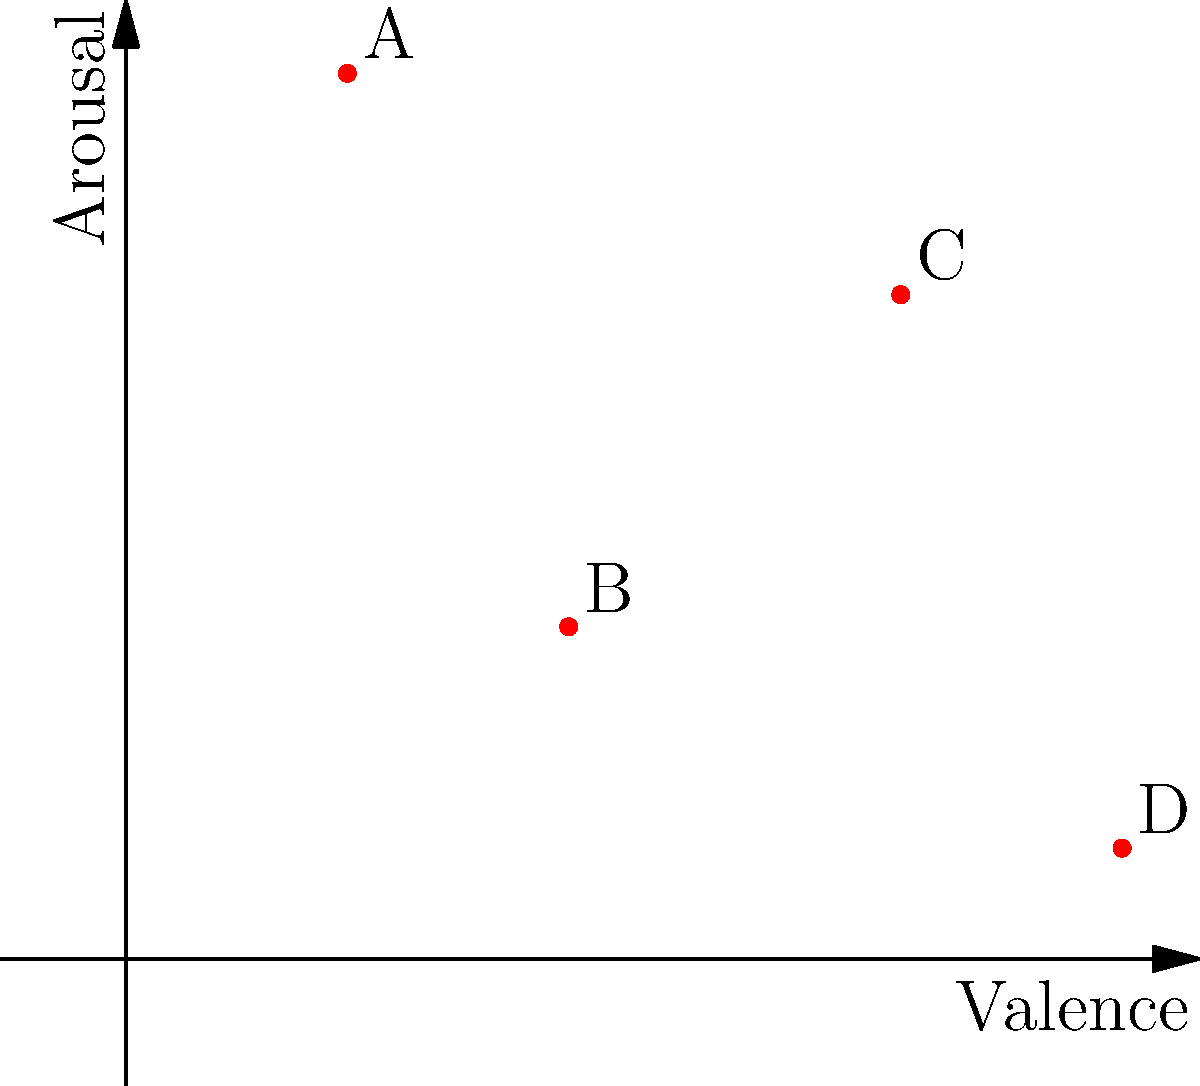In the valence-arousal plot above, which song is most likely to be perceived as calm and relaxing? To determine which song is most likely to be perceived as calm and relaxing, we need to analyze the valence-arousal plot:

1. Understand the axes:
   - Valence (x-axis): Represents the musical positiveness conveyed by a track. Higher values indicate more positive emotions.
   - Arousal (y-axis): Represents the intensity or energy level of a track. Higher values indicate more energetic or intense emotions.

2. Characteristics of calm and relaxing music:
   - Typically has moderate to high valence (positive emotion)
   - Typically has low arousal (low energy/intensity)

3. Analyze each song's position:
   - Song A: High arousal, low valence (energetic but negative)
   - Song B: Low arousal, moderate valence (low energy, slightly positive)
   - Song C: Moderate arousal, high valence (moderately energetic, very positive)
   - Song D: Very low arousal, very high valence (very low energy, very positive)

4. Compare the songs:
   Song D has the lowest arousal and highest valence, making it the most likely to be perceived as calm and relaxing.
Answer: D 